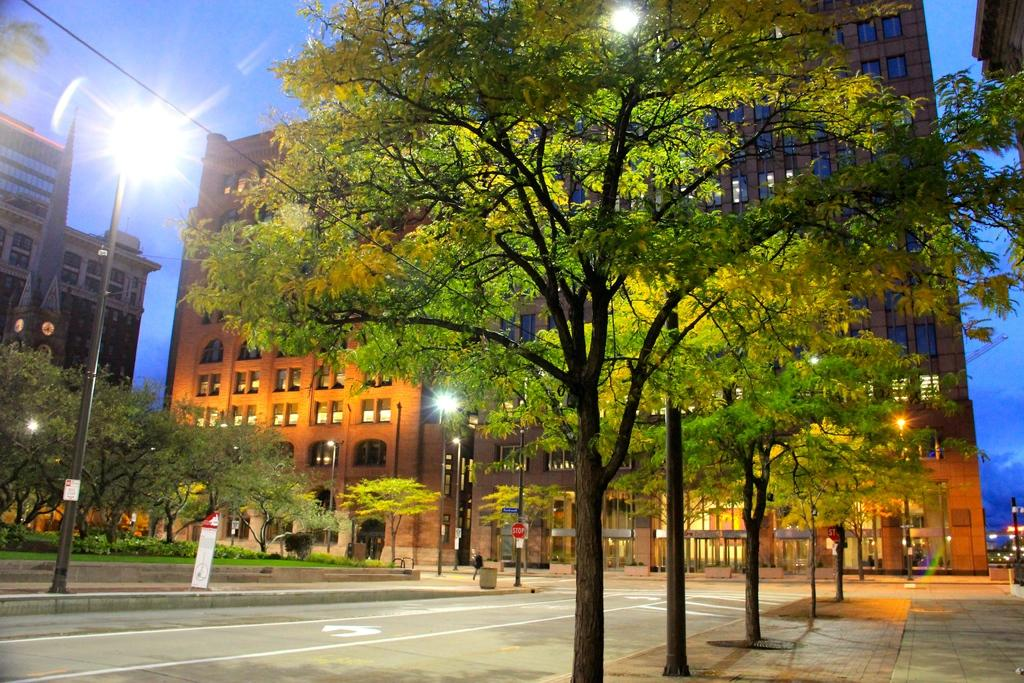What type of vegetation can be seen in the image? There are trees, grass, and plants in the image. What type of infrastructure is present in the image? There is a road, poles, lights, and buildings in the image. What is the background of the image composed of? The background of the image includes sky and buildings. What is the primary material visible in the image? The primary materials visible in the image are trees, grass, and buildings. How much sugar is present in the image? There is no sugar present in the image; it features trees, a road, poles, lights, grass, a wire, plants, buildings, and sky. Is there a hill visible in the image? There is no hill present in the image; it features trees, a road, poles, lights, grass, a wire, plants, buildings, and sky. 